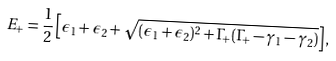<formula> <loc_0><loc_0><loc_500><loc_500>E _ { + } = \frac { 1 } { 2 } \left [ \epsilon _ { 1 } + \epsilon _ { 2 } + \sqrt { ( \epsilon _ { 1 } + \epsilon _ { 2 } ) ^ { 2 } + \Gamma _ { + } ( \Gamma _ { + } - \gamma _ { 1 } - \gamma _ { 2 } ) } \right ] ,</formula> 